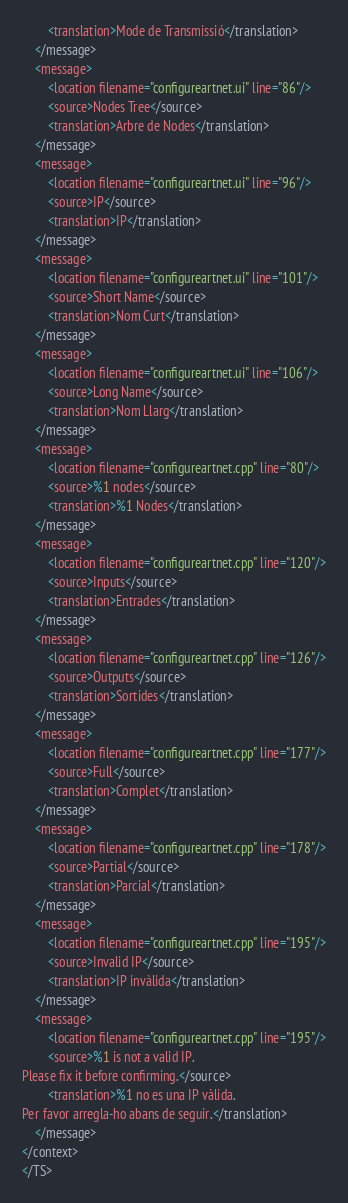Convert code to text. <code><loc_0><loc_0><loc_500><loc_500><_TypeScript_>        <translation>Mode de Transmissió</translation>
    </message>
    <message>
        <location filename="configureartnet.ui" line="86"/>
        <source>Nodes Tree</source>
        <translation>Arbre de Nodes</translation>
    </message>
    <message>
        <location filename="configureartnet.ui" line="96"/>
        <source>IP</source>
        <translation>IP</translation>
    </message>
    <message>
        <location filename="configureartnet.ui" line="101"/>
        <source>Short Name</source>
        <translation>Nom Curt</translation>
    </message>
    <message>
        <location filename="configureartnet.ui" line="106"/>
        <source>Long Name</source>
        <translation>Nom Llarg</translation>
    </message>
    <message>
        <location filename="configureartnet.cpp" line="80"/>
        <source>%1 nodes</source>
        <translation>%1 Nodes</translation>
    </message>
    <message>
        <location filename="configureartnet.cpp" line="120"/>
        <source>Inputs</source>
        <translation>Entrades</translation>
    </message>
    <message>
        <location filename="configureartnet.cpp" line="126"/>
        <source>Outputs</source>
        <translation>Sortides</translation>
    </message>
    <message>
        <location filename="configureartnet.cpp" line="177"/>
        <source>Full</source>
        <translation>Complet</translation>
    </message>
    <message>
        <location filename="configureartnet.cpp" line="178"/>
        <source>Partial</source>
        <translation>Parcial</translation>
    </message>
    <message>
        <location filename="configureartnet.cpp" line="195"/>
        <source>Invalid IP</source>
        <translation>IP invàlida</translation>
    </message>
    <message>
        <location filename="configureartnet.cpp" line="195"/>
        <source>%1 is not a valid IP.
Please fix it before confirming.</source>
        <translation>%1 no es una IP vàlida.
Per favor arregla-ho abans de seguir.</translation>
    </message>
</context>
</TS>
</code> 